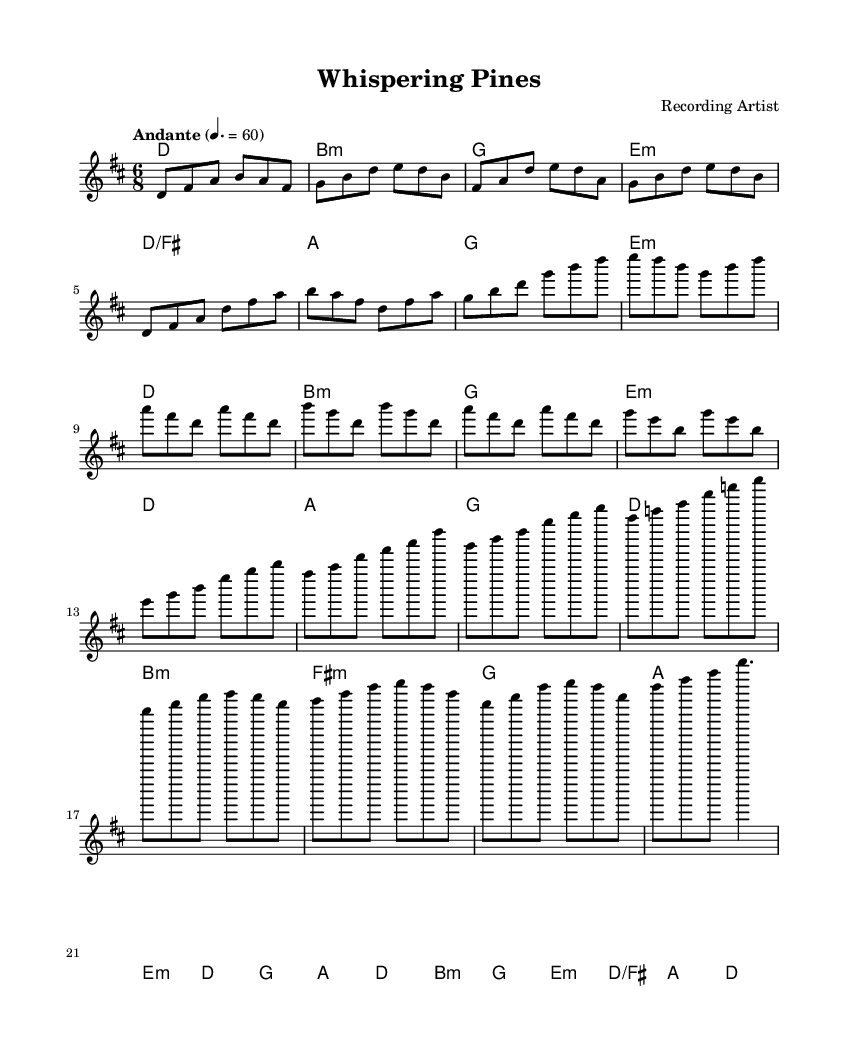What is the key signature of this music? The key signature is D major, which has two sharps: F sharp and C sharp. This is indicated at the beginning of the staff in the key signature indicator.
Answer: D major What is the time signature of this music? The time signature is written at the beginning of the score and is indicated as 6/8, meaning there are six eighth-note beats in each measure.
Answer: 6/8 What is the tempo marking given for this music? The tempo marking is specified in the score as "Andante," which refers to a moderate speed of music usually around 76 to 108 beats per minute. This is followed by a metronome marking of 60, suggesting a slow pace.
Answer: Andante How many measures are there in the chord progression of the verse? By examining the chord section, we can count the measures that are presented in the verse. There are a total of 4 measures listed for the verse.
Answer: 4 What is the first chord of the piece? Looking at the chord progression at the beginning of the score, the first chord indicated is D major, which is confirmed by the key signature of the piece.
Answer: D Which section follows the chorus in this piece? After analyzing the structure given in the score, it’s clear that the section labeled after the chorus is the bridge, which is characterized by different harmonic progressions compared to the preceding sections.
Answer: Bridge What type of musical composition does the title suggest? The title "Whispering Pines" implies a connection to nature, indicating that this is an intricate fingerstyle guitar composition inspired by landscapes, as suggested by the evocative imagery of the title itself.
Answer: Fingerstyle 